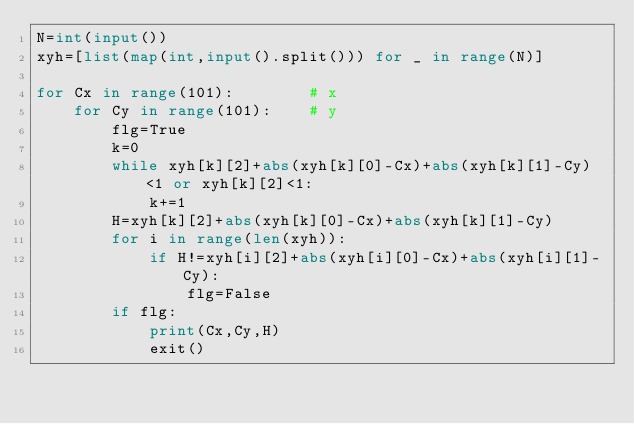Convert code to text. <code><loc_0><loc_0><loc_500><loc_500><_Python_>N=int(input())
xyh=[list(map(int,input().split())) for _ in range(N)]

for Cx in range(101):        # x
    for Cy in range(101):    # y
        flg=True
        k=0
        while xyh[k][2]+abs(xyh[k][0]-Cx)+abs(xyh[k][1]-Cy) <1 or xyh[k][2]<1:
            k+=1
        H=xyh[k][2]+abs(xyh[k][0]-Cx)+abs(xyh[k][1]-Cy)
        for i in range(len(xyh)):
            if H!=xyh[i][2]+abs(xyh[i][0]-Cx)+abs(xyh[i][1]-Cy):
                flg=False
        if flg:
            print(Cx,Cy,H)
            exit()</code> 